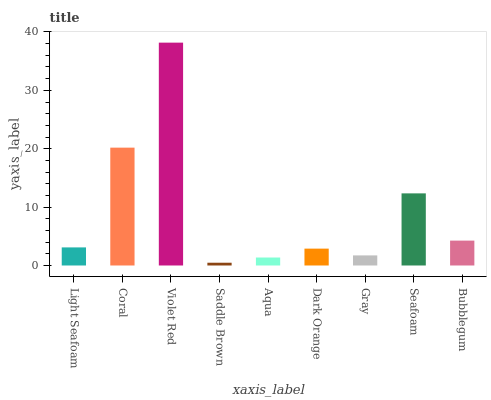Is Saddle Brown the minimum?
Answer yes or no. Yes. Is Violet Red the maximum?
Answer yes or no. Yes. Is Coral the minimum?
Answer yes or no. No. Is Coral the maximum?
Answer yes or no. No. Is Coral greater than Light Seafoam?
Answer yes or no. Yes. Is Light Seafoam less than Coral?
Answer yes or no. Yes. Is Light Seafoam greater than Coral?
Answer yes or no. No. Is Coral less than Light Seafoam?
Answer yes or no. No. Is Light Seafoam the high median?
Answer yes or no. Yes. Is Light Seafoam the low median?
Answer yes or no. Yes. Is Coral the high median?
Answer yes or no. No. Is Coral the low median?
Answer yes or no. No. 